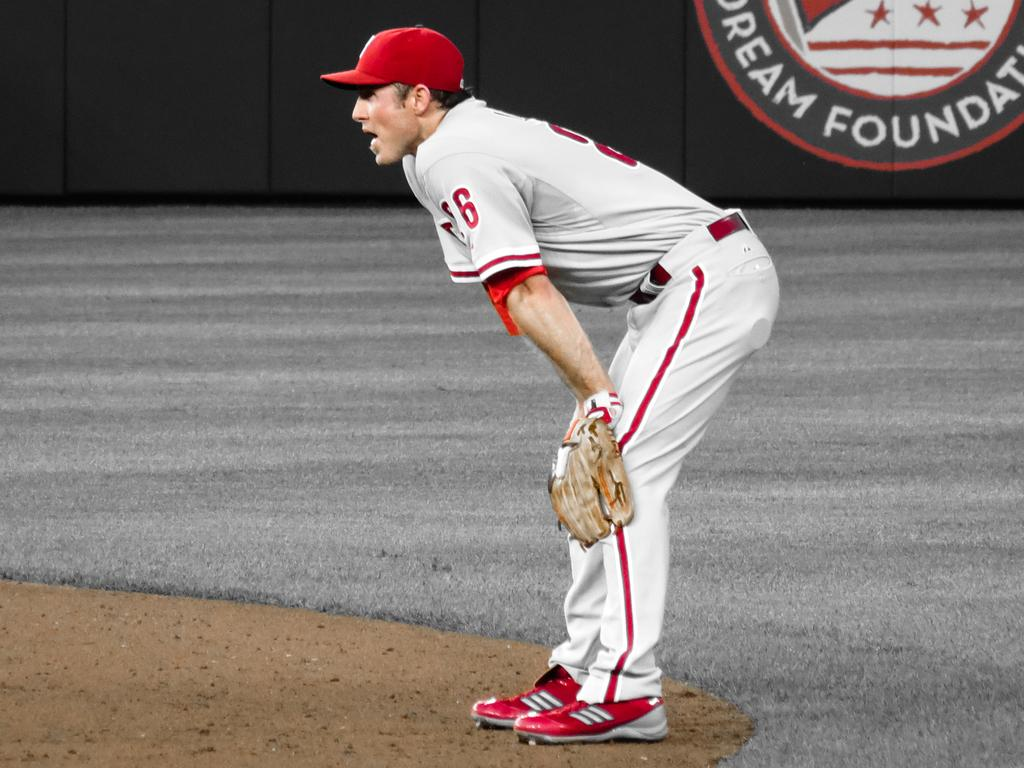Provide a one-sentence caption for the provided image. A baseball fielder is seen in front of a Dream Foundation sign on the outfield wall. 